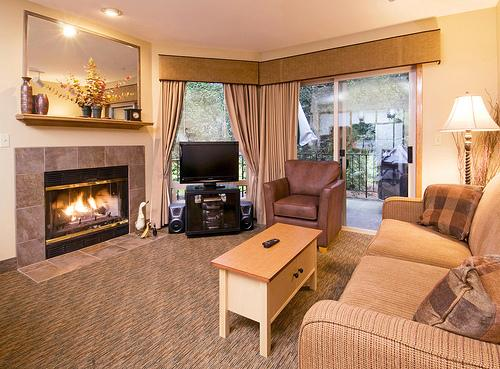What is the primary purpose of the room depicted in the image? The primary purpose of the room is a family living space for relaxation and entertainment, featuring comfortable seating and a television set. Mention the prominent objects related to entertainment in the room. A large flat screen TV is placed on a stand with a speaker next to it, and there is a black TV remote on the coffee table. Describe the scene with a focus on colors and textures of the objects present. A warm-hued living room with a blend of wooden, leather, and fabric textures, featuring a brown couch, a dark brown chair, a wooden coffee table, and a soft carpet. Describe the atmosphere and style of the room in the image. A cozy, traditional style family room featuring a fireplace with a fire in it, a comfortable brown leather armchair and sofa, and a wooden coffee table on muted wall-to-wall carpeting. Provide a brief overview of the scene depicted in the image. A neatly arranged living room with a fireplace, a brown couch, a wooden coffee table, a tv on a stand, and a dark brown chair, surrounded by various decorations and furnishings. State the room's appearance and general layout. The room is a neat, clean, and organized family living area, with furniture arranged around a central fireplace and a TV on a stand. Describe the main furniture pieces present in the image. The image features a brown couch, a wooden coffee table, a dark brown chair, a TV on a stand, and a lamp by the couch. Explain the focal point of the image with its surroundings. A neat and clean family room with traditional style furnishings like a fireplace with a large mirror above it, a brown couch, a wooden coffee table, and a TV on a stand. Enumerate some decorative elements seen in the image. A large mirror above the fireplace, a set of vases on a shelf, a potted plant, a floor lamp with a white shade, and plaid pillows over the sofa. Mention a few objects that make the room look cozy and comfortable. A brown couch with plaid pillows, a dark brown chair, a fire in the fireplace, and a floor lamp with a white shade create a cozy atmosphere. 